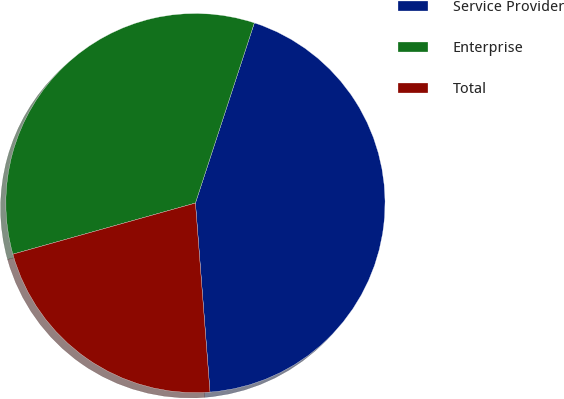<chart> <loc_0><loc_0><loc_500><loc_500><pie_chart><fcel>Service Provider<fcel>Enterprise<fcel>Total<nl><fcel>43.75%<fcel>34.38%<fcel>21.88%<nl></chart> 